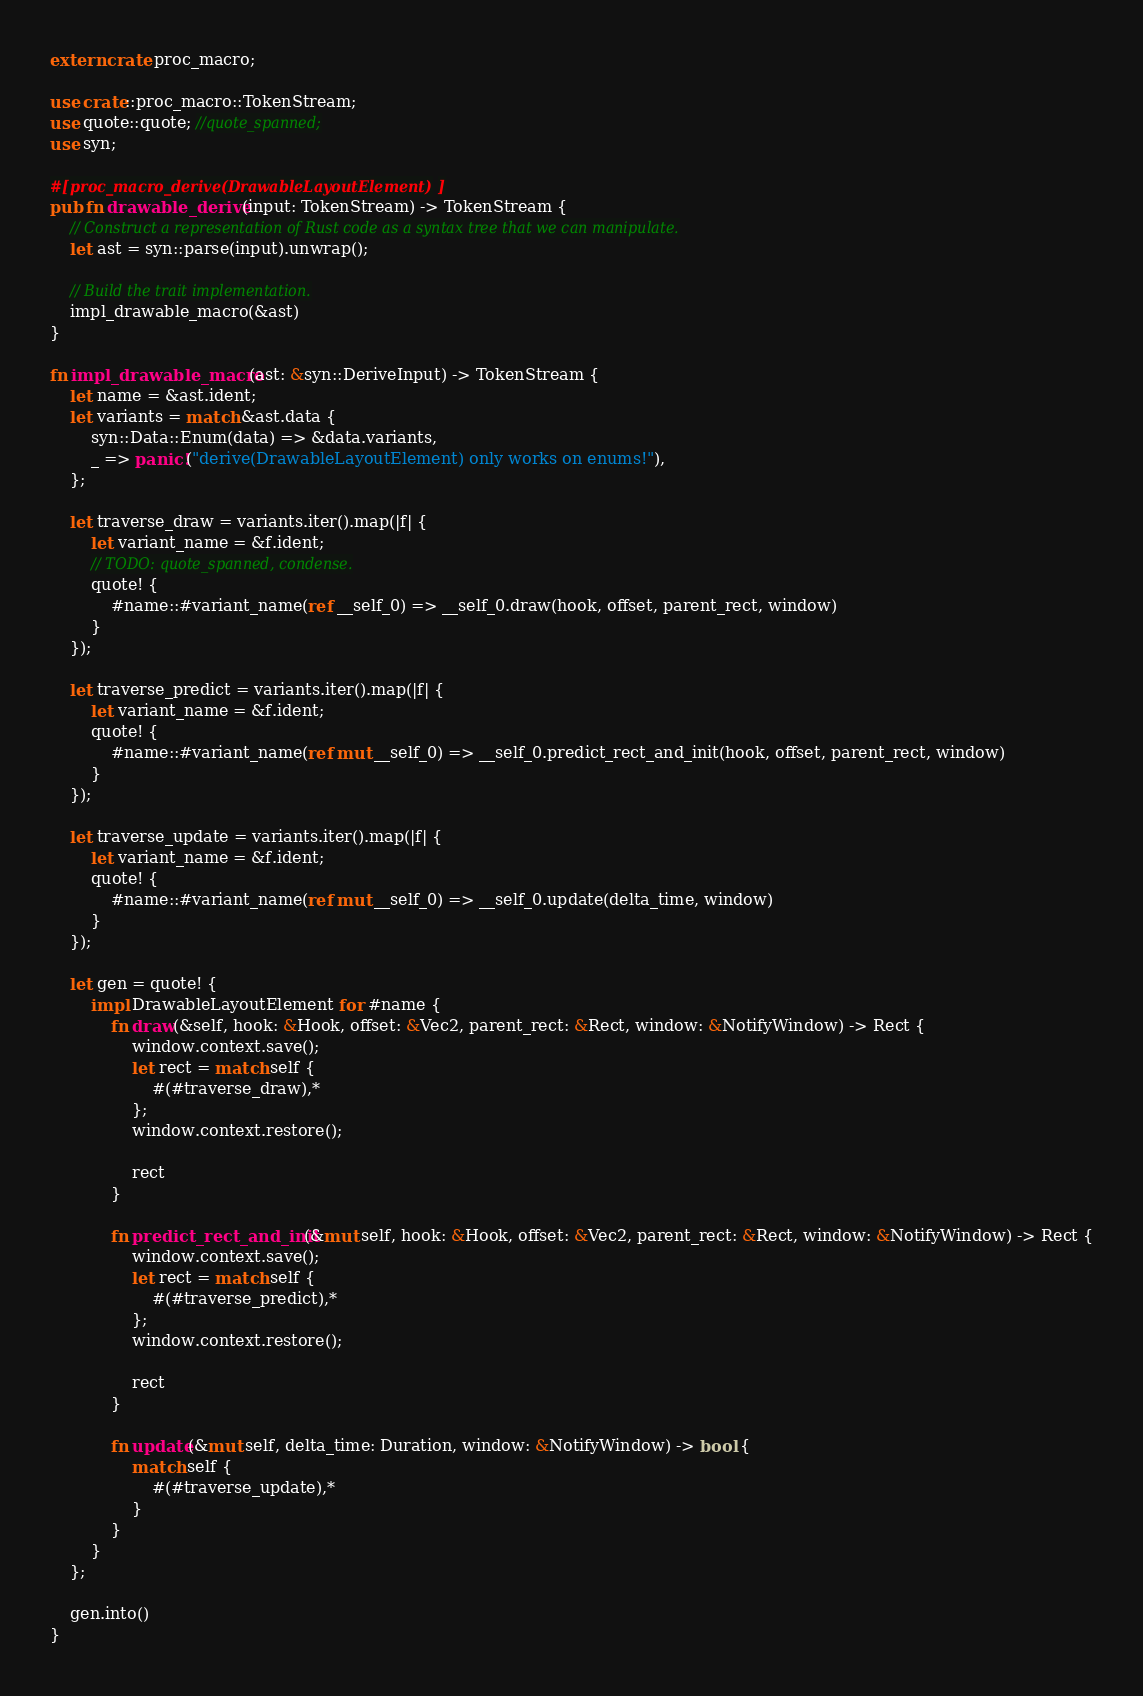Convert code to text. <code><loc_0><loc_0><loc_500><loc_500><_Rust_>extern crate proc_macro;

use crate::proc_macro::TokenStream;
use quote::quote; //quote_spanned;
use syn;

#[proc_macro_derive(DrawableLayoutElement)]
pub fn drawable_derive(input: TokenStream) -> TokenStream {
    // Construct a representation of Rust code as a syntax tree that we can manipulate.
    let ast = syn::parse(input).unwrap();

    // Build the trait implementation.
    impl_drawable_macro(&ast)
}

fn impl_drawable_macro(ast: &syn::DeriveInput) -> TokenStream {
    let name = &ast.ident;
    let variants = match &ast.data {
        syn::Data::Enum(data) => &data.variants,
        _ => panic!("derive(DrawableLayoutElement) only works on enums!"),
    };

    let traverse_draw = variants.iter().map(|f| {
        let variant_name = &f.ident;
        // TODO: quote_spanned, condense.
        quote! {
            #name::#variant_name(ref __self_0) => __self_0.draw(hook, offset, parent_rect, window)
        }
    });

    let traverse_predict = variants.iter().map(|f| {
        let variant_name = &f.ident;
        quote! {
            #name::#variant_name(ref mut __self_0) => __self_0.predict_rect_and_init(hook, offset, parent_rect, window)
        }
    });

    let traverse_update = variants.iter().map(|f| {
        let variant_name = &f.ident;
        quote! {
            #name::#variant_name(ref mut __self_0) => __self_0.update(delta_time, window)
        }
    });

    let gen = quote! {
        impl DrawableLayoutElement for #name {
            fn draw(&self, hook: &Hook, offset: &Vec2, parent_rect: &Rect, window: &NotifyWindow) -> Rect {
                window.context.save();
                let rect = match self {
                    #(#traverse_draw),*
                };
                window.context.restore();

                rect
            }

            fn predict_rect_and_init(&mut self, hook: &Hook, offset: &Vec2, parent_rect: &Rect, window: &NotifyWindow) -> Rect {
                window.context.save();
                let rect = match self {
                    #(#traverse_predict),*
                };
                window.context.restore();

                rect
            }

            fn update(&mut self, delta_time: Duration, window: &NotifyWindow) -> bool { 
                match self {
                    #(#traverse_update),*
                }
            }
        }
    };

    gen.into()
}


</code> 